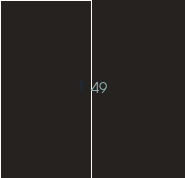<code> <loc_0><loc_0><loc_500><loc_500><_SQL_>49
</code> 